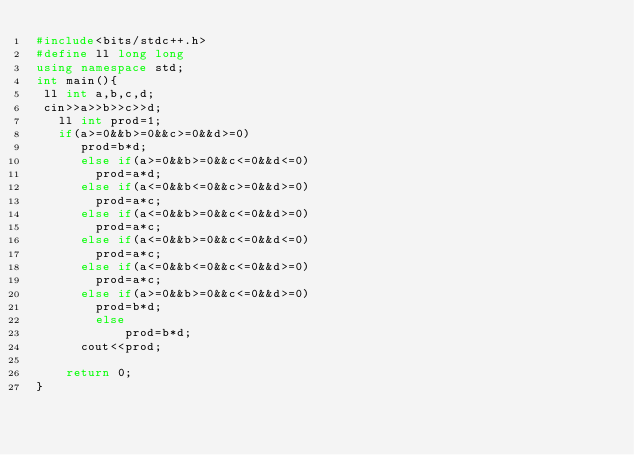<code> <loc_0><loc_0><loc_500><loc_500><_C++_>#include<bits/stdc++.h>
#define ll long long
using namespace std;
int main(){
 ll int a,b,c,d;
 cin>>a>>b>>c>>d;
   ll int prod=1;
   if(a>=0&&b>=0&&c>=0&&d>=0)
      prod=b*d;
      else if(a>=0&&b>=0&&c<=0&&d<=0)
        prod=a*d;
      else if(a<=0&&b<=0&&c>=0&&d>=0)
        prod=a*c;
      else if(a<=0&&b>=0&&c<=0&&d>=0)
        prod=a*c;
      else if(a<=0&&b>=0&&c<=0&&d<=0)
        prod=a*c;
      else if(a<=0&&b<=0&&c<=0&&d>=0)
        prod=a*c;
      else if(a>=0&&b>=0&&c<=0&&d>=0)
        prod=b*d;
        else
            prod=b*d;
      cout<<prod;

    return 0;
}
</code> 